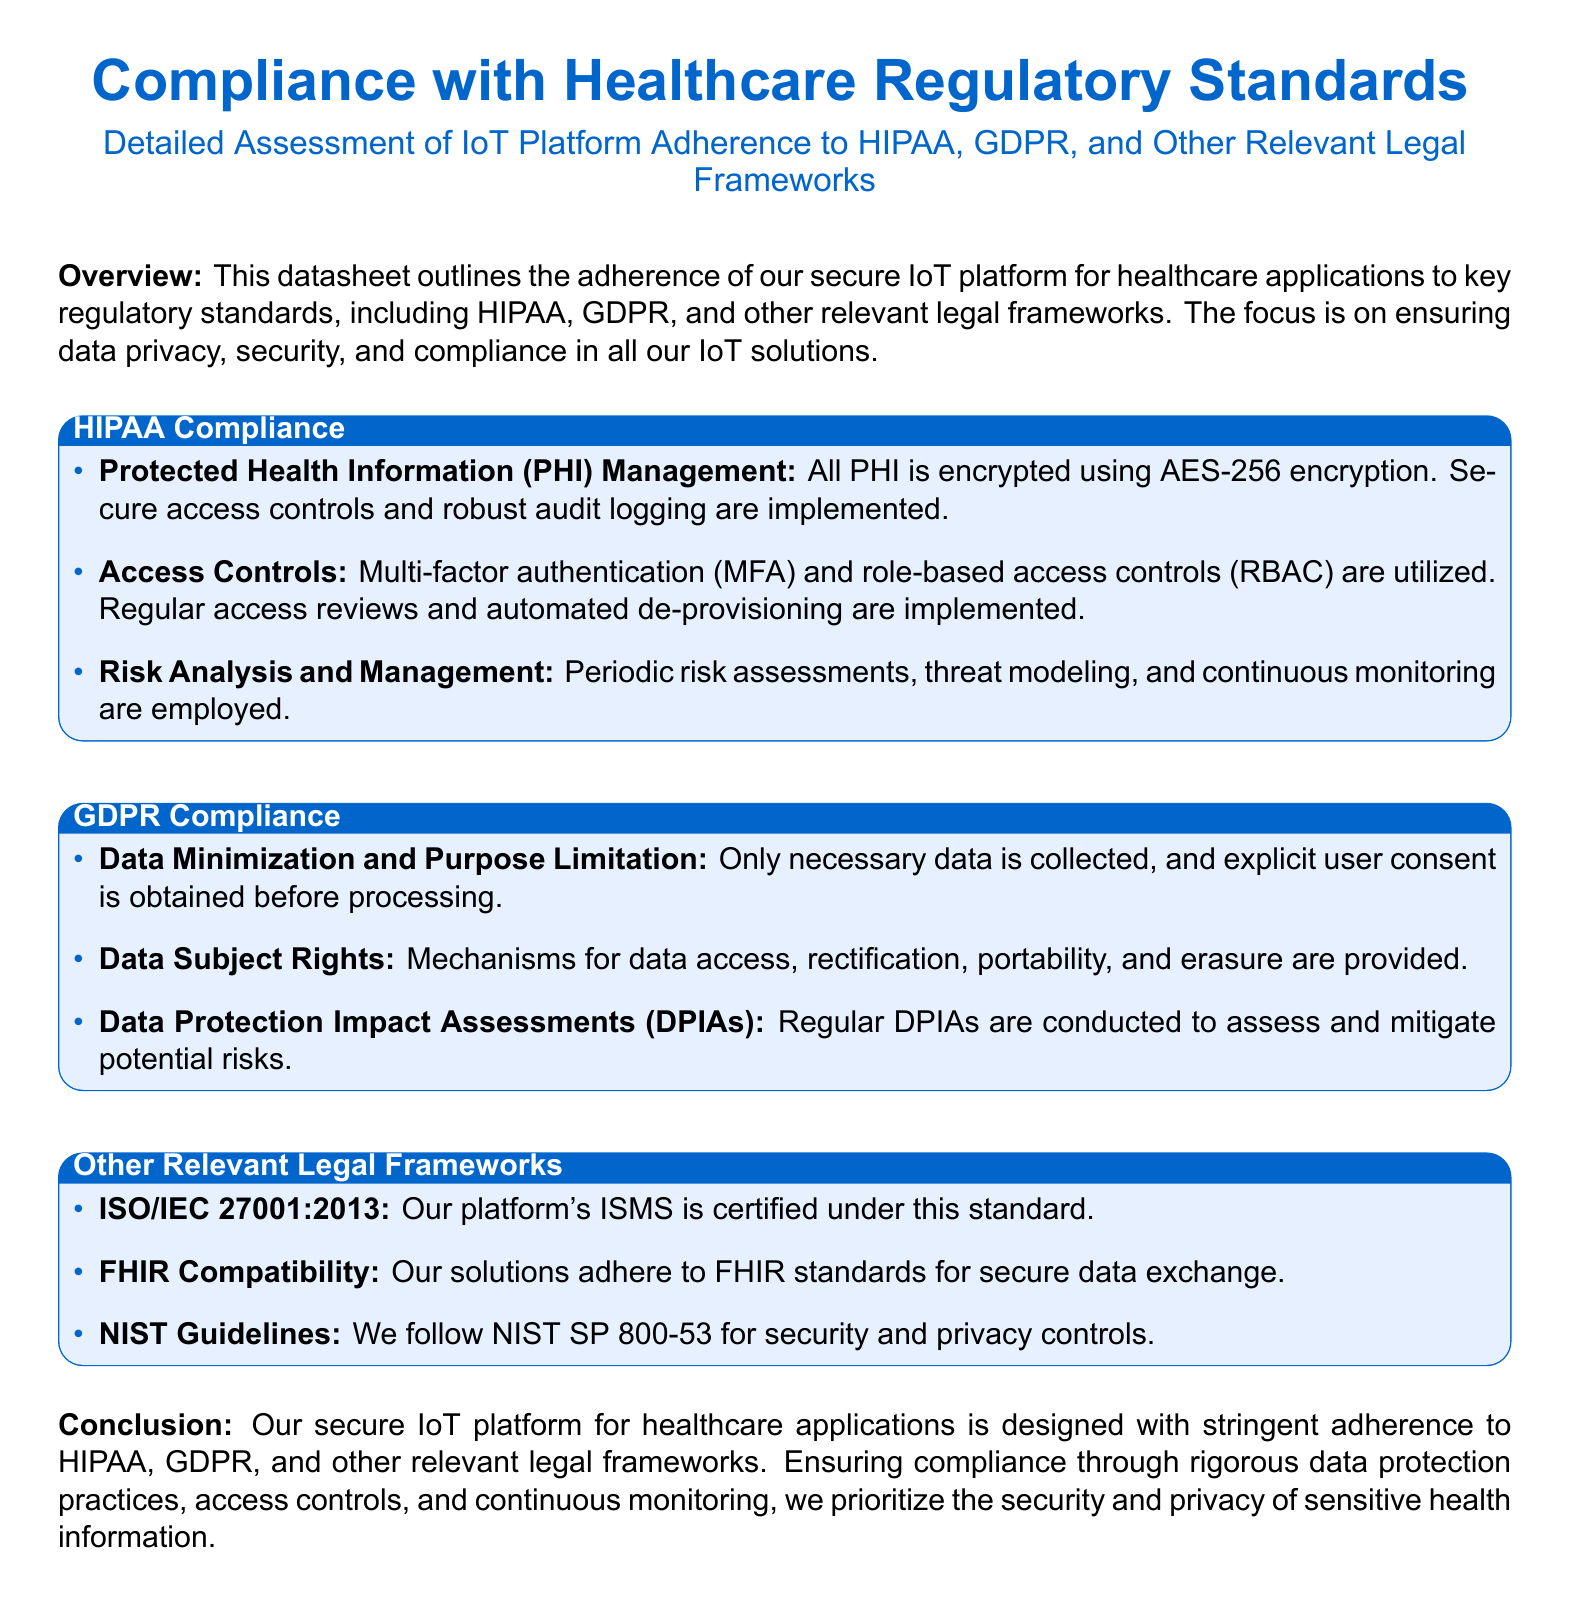What is the encryption standard used for PHI? The document states that all PHI is encrypted using AES-256 encryption.
Answer: AES-256 encryption What authentication method is mentioned under access controls? The document mentions that multi-factor authentication (MFA) is utilized under access controls.
Answer: Multi-factor authentication (MFA) How often are Data Protection Impact Assessments (DPIAs) conducted? The document indicates that regular DPIAs are conducted to assess risks.
Answer: Regularly Which standard is mentioned for the Information Security Management System? The document states that the platform's ISMS is certified under ISO/IEC 27001:2013.
Answer: ISO/IEC 27001:2013 What rights are provided for data subjects? The document mentions data access, rectification, portability, and erasure rights for data subjects.
Answer: Data access, rectification, portability, and erasure What model is used for risk analysis and management? The document states that threat modeling is employed as part of risk analysis and management.
Answer: Threat modeling What is the main focus of the datasheet? The document states that the focus is on ensuring data privacy, security, and compliance in IoT solutions.
Answer: Data privacy, security, and compliance How many frameworks are specifically mentioned in the compliance section? The document outlines adherence to HIPAA, GDPR, and other legal frameworks.
Answer: Three What does FHIR stand for? The document indicates that the solutions are FHIR compatible for secure data exchange, though it does not spell out the acronym.
Answer: FHIR 